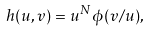Convert formula to latex. <formula><loc_0><loc_0><loc_500><loc_500>h ( u , v ) = u ^ { N } \phi ( v / u ) ,</formula> 